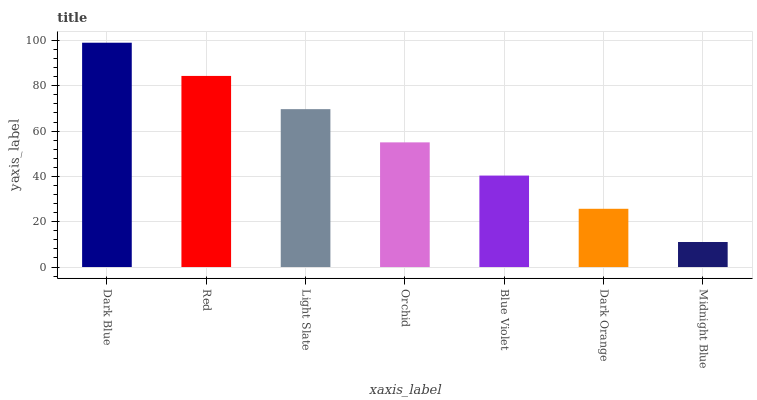Is Red the minimum?
Answer yes or no. No. Is Red the maximum?
Answer yes or no. No. Is Dark Blue greater than Red?
Answer yes or no. Yes. Is Red less than Dark Blue?
Answer yes or no. Yes. Is Red greater than Dark Blue?
Answer yes or no. No. Is Dark Blue less than Red?
Answer yes or no. No. Is Orchid the high median?
Answer yes or no. Yes. Is Orchid the low median?
Answer yes or no. Yes. Is Midnight Blue the high median?
Answer yes or no. No. Is Light Slate the low median?
Answer yes or no. No. 